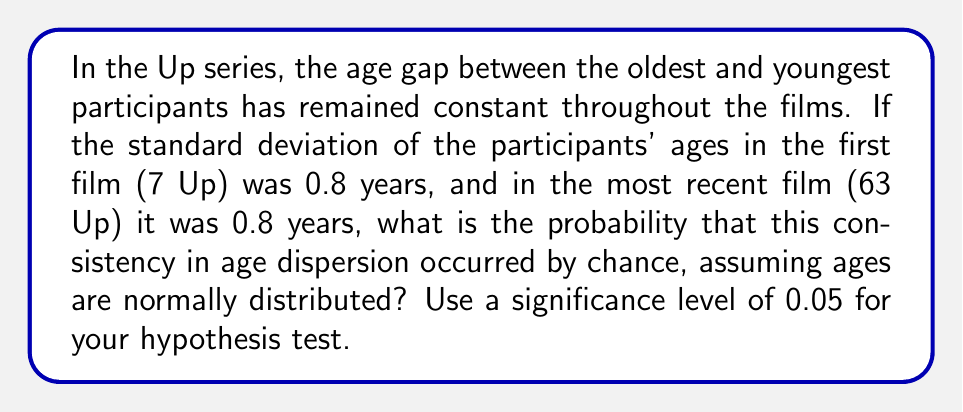Can you answer this question? To analyze the statistical significance of the consistent age dispersion, we'll use an F-test for equality of variances. The steps are as follows:

1. State the null and alternative hypotheses:
   $H_0: \sigma_1^2 = \sigma_2^2$ (variances are equal)
   $H_a: \sigma_1^2 \neq \sigma_2^2$ (variances are not equal)

2. Calculate the F-statistic:
   $F = \frac{s_1^2}{s_2^2}$, where $s_1^2$ and $s_2^2$ are the sample variances

   Since the standard deviations are equal (0.8 years), the variances are also equal:
   $s_1^2 = s_2^2 = 0.8^2 = 0.64$

   $F = \frac{0.64}{0.64} = 1$

3. Determine the degrees of freedom:
   $df_1 = df_2 = n - 1$, where n is the number of participants (14 in the Up series)
   $df_1 = df_2 = 13$

4. Find the critical F-values for a two-tailed test at α = 0.05:
   $F_{critical(lower)} = \frac{1}{F_{0.025, 13, 13}} = \frac{1}{2.577} = 0.388$
   $F_{critical(upper)} = F_{0.025, 13, 13} = 2.577$

5. Compare the F-statistic to the critical values:
   $0.388 < 1 < 2.577$
   The F-statistic falls within the non-rejection region.

6. Calculate the p-value:
   $p-value = 2 * P(F > 1) = 2 * 0.5 = 1$

7. Compare the p-value to the significance level:
   $1 > 0.05$

Since the p-value is greater than the significance level, we fail to reject the null hypothesis. This means there is not enough evidence to conclude that the variances are significantly different.
Answer: $p-value = 1$, fail to reject $H_0$ 